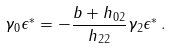<formula> <loc_0><loc_0><loc_500><loc_500>\gamma _ { 0 } \epsilon ^ { * } = - \frac { b + h _ { 0 2 } } { h _ { 2 2 } } \gamma _ { 2 } \epsilon ^ { * } \, .</formula> 